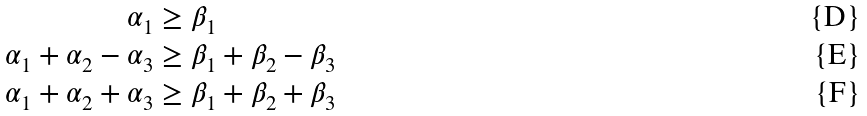Convert formula to latex. <formula><loc_0><loc_0><loc_500><loc_500>\alpha _ { 1 } & \geq \beta _ { 1 } \\ \alpha _ { 1 } + \alpha _ { 2 } - \alpha _ { 3 } & \geq \beta _ { 1 } + \beta _ { 2 } - \beta _ { 3 } \\ \alpha _ { 1 } + \alpha _ { 2 } + \alpha _ { 3 } & \geq \beta _ { 1 } + \beta _ { 2 } + \beta _ { 3 }</formula> 